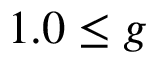Convert formula to latex. <formula><loc_0><loc_0><loc_500><loc_500>1 . 0 \leq g</formula> 